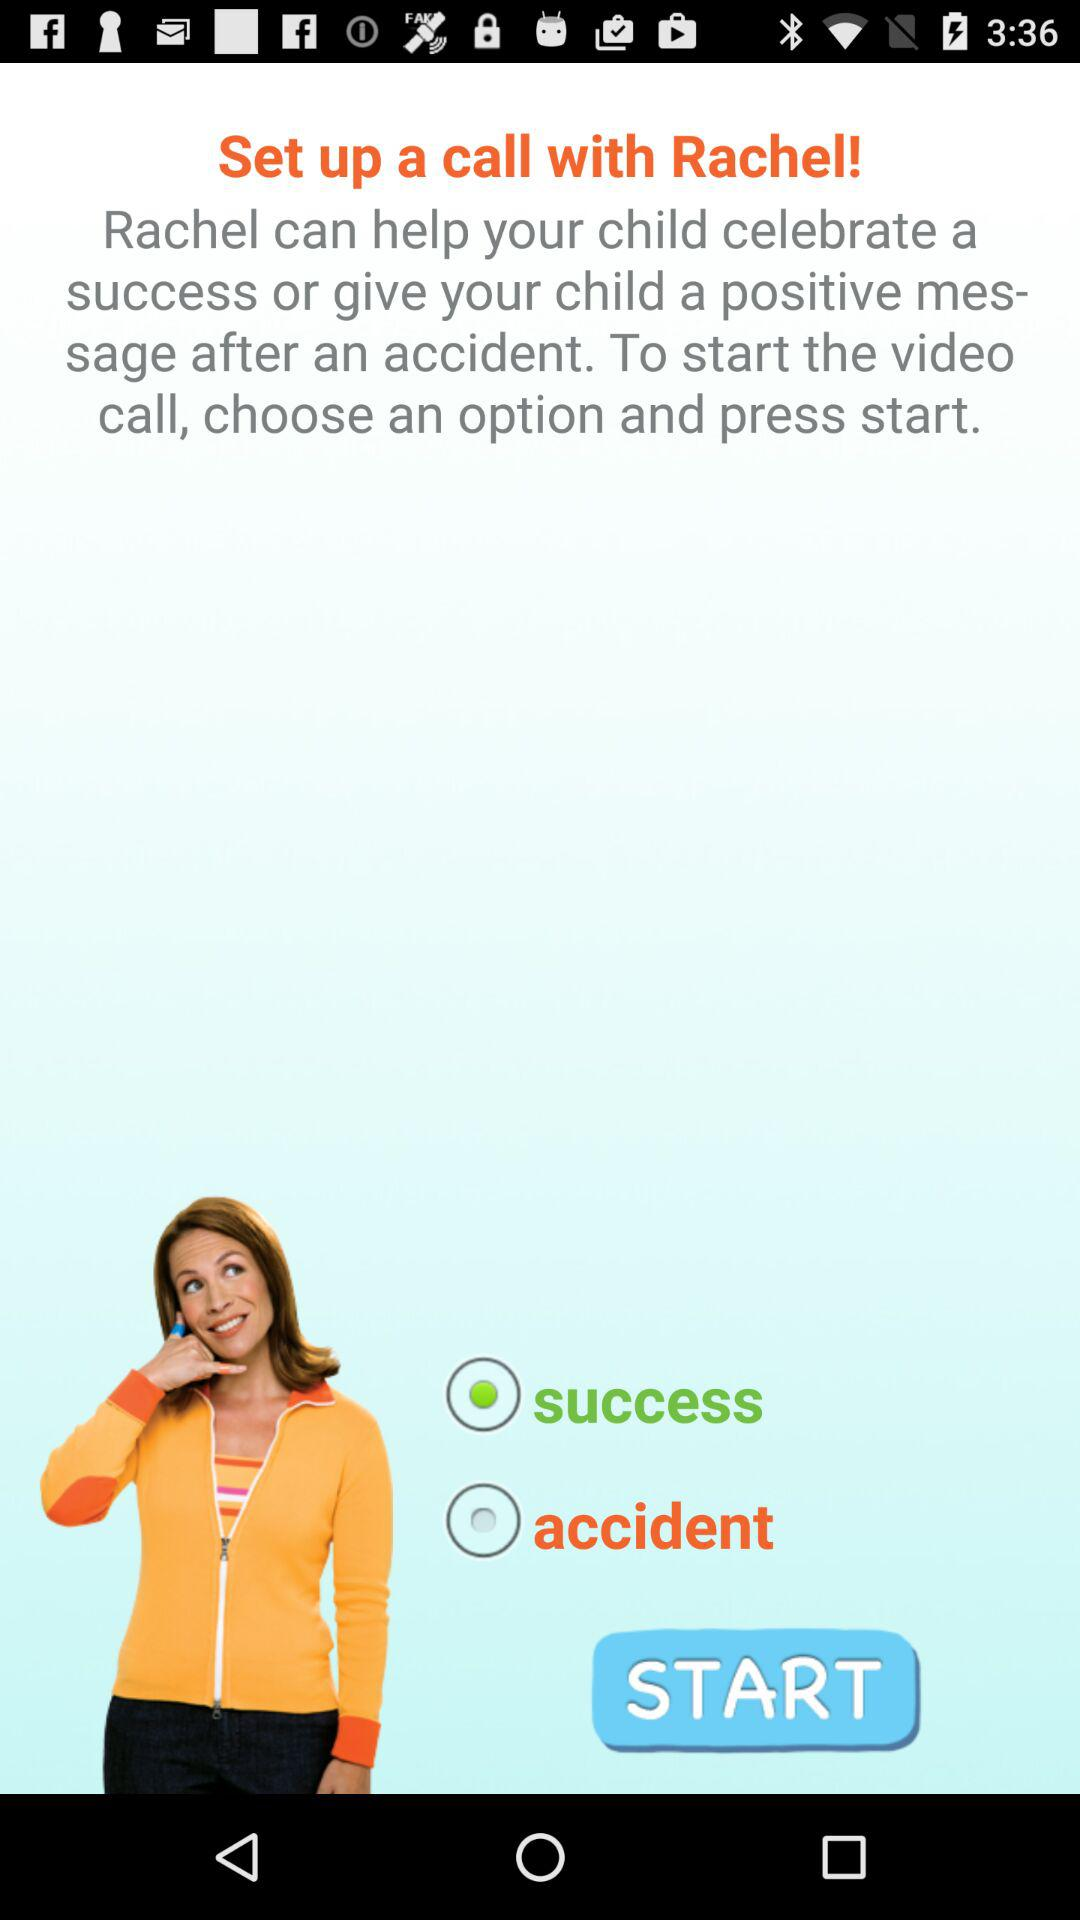With whom to set up a call? Set up a call with Rachel. 